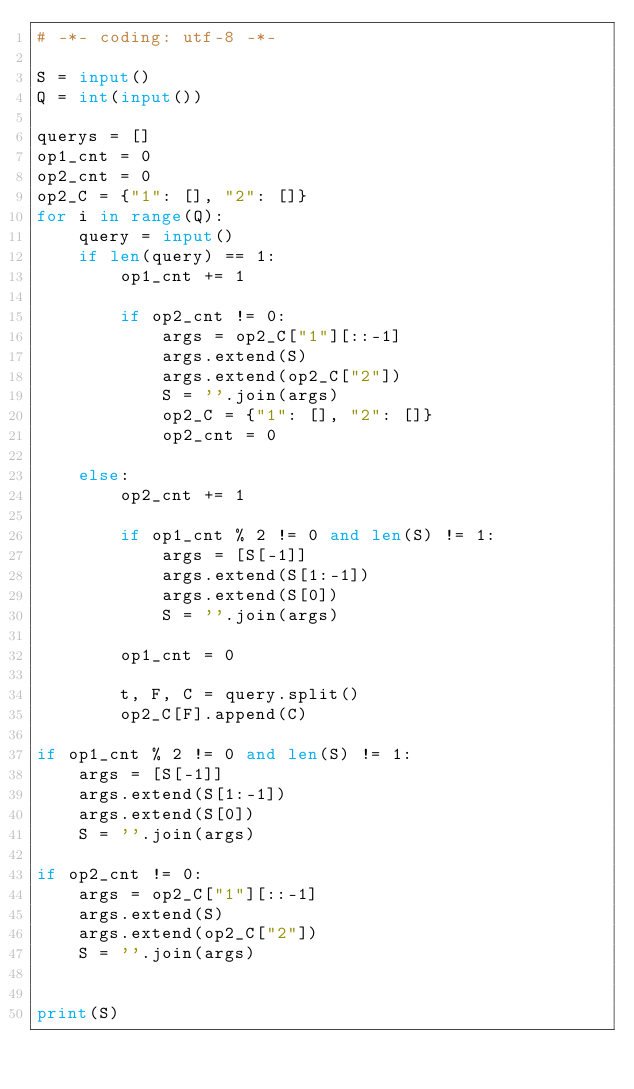<code> <loc_0><loc_0><loc_500><loc_500><_Python_># -*- coding: utf-8 -*-

S = input()
Q = int(input())

querys = []
op1_cnt = 0
op2_cnt = 0
op2_C = {"1": [], "2": []}
for i in range(Q):
    query = input()
    if len(query) == 1:
        op1_cnt += 1

        if op2_cnt != 0:
            args = op2_C["1"][::-1]
            args.extend(S)
            args.extend(op2_C["2"])
            S = ''.join(args)
            op2_C = {"1": [], "2": []}
            op2_cnt = 0

    else:
        op2_cnt += 1

        if op1_cnt % 2 != 0 and len(S) != 1:
            args = [S[-1]]
            args.extend(S[1:-1])
            args.extend(S[0])
            S = ''.join(args)

        op1_cnt = 0

        t, F, C = query.split()
        op2_C[F].append(C)

if op1_cnt % 2 != 0 and len(S) != 1:
    args = [S[-1]]
    args.extend(S[1:-1])
    args.extend(S[0])
    S = ''.join(args)

if op2_cnt != 0:
    args = op2_C["1"][::-1]
    args.extend(S)
    args.extend(op2_C["2"])
    S = ''.join(args)


print(S)
</code> 